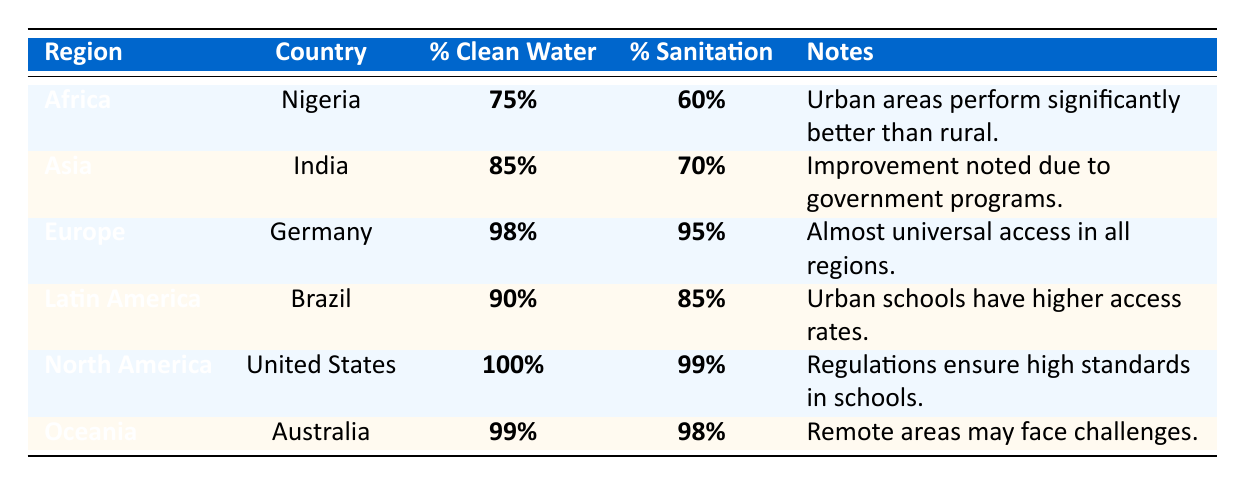What is the percentage of schools in North America with access to clean water? The table lists the United States under North America with a percentage of 100% for access to clean water.
Answer: 100% Which country in Africa has the lowest percentage of sanitation facilities in schools? The table shows Nigeria under Africa with a sanitation percentage of 60%, which is lower compared to other countries listed.
Answer: Nigeria What is the difference in percentage of clean water access between schools in India and schools in Germany? The clean water access in India is 85%, and in Germany, it is 98%. The difference is 98% - 85% = 13%.
Answer: 13% Is it true that all regions have at least 75% access to clean water in schools? The table indicates that Africa (75%) and Asia (85%) have access to clean water, with every other region above 85%. This confirms that all regions shown have at least 75% access.
Answer: Yes Which region shows almost universal access to sanitation in schools? Looking at the table, Germany in Europe has a sanitation percentage of 95%, which is the highest listed. This implies almost universal access in the region.
Answer: Europe What is the average percentage of sanitation facilities in schools across the listed countries? The percentages for sanitation are 60% (Nigeria), 70% (India), 95% (Germany), 85% (Brazil), 99% (United States), and 98% (Australia), summing these gives 60 + 70 + 95 + 85 + 99 + 98 = 507. Dividing by 6 gives an average of 507/6 = 84.5%.
Answer: 84.5% Which region has the highest percentage of access to sanitation facilities? The United States in North America has a sanitation percentage of 99%, which is the highest when compared to other regions listed.
Answer: North America From the data, which regions have better access to clean water, urban or rural areas, in Nigeria? The note associated with Nigeria mentions that urban areas perform significantly better than rural areas, indicating urban areas have better access.
Answer: Urban areas How does Brazil's sanitation percentage compare to that of India? Brazil's sanitation is 85%, while India’s is 70%. Therefore, Brazil has a higher percentage of sanitation facilities compared to India.
Answer: Brazil has a higher percentage In Oceania, what are the sanitation percentages in schools? The table states that Australia has a sanitation percentage of 98%, which indicates that schools in this region have high access to sanitation facilities.
Answer: 98% 